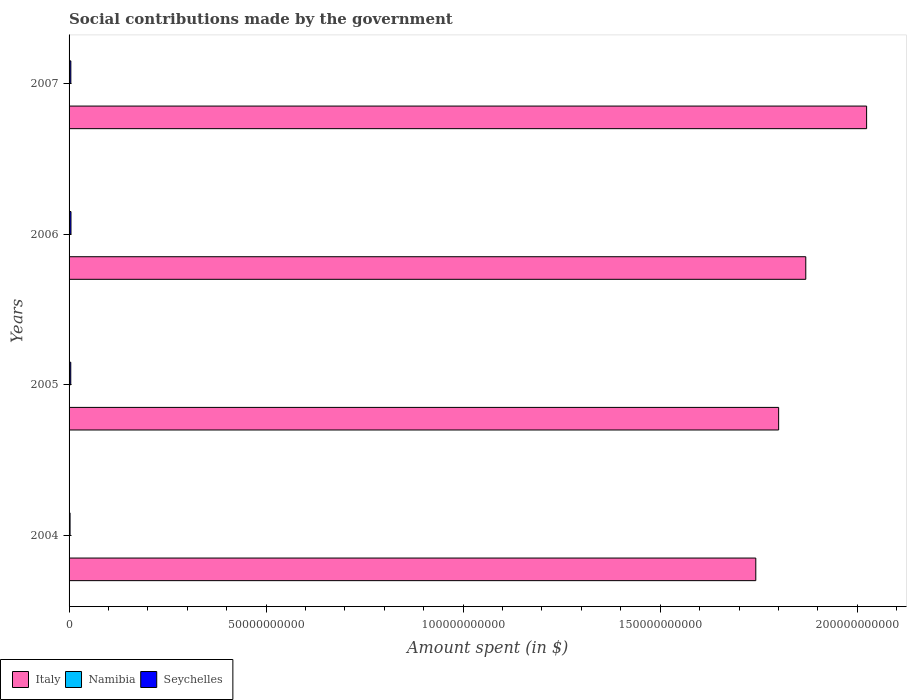How many different coloured bars are there?
Ensure brevity in your answer.  3. How many groups of bars are there?
Provide a succinct answer. 4. Are the number of bars on each tick of the Y-axis equal?
Keep it short and to the point. Yes. How many bars are there on the 4th tick from the bottom?
Offer a terse response. 3. In how many cases, is the number of bars for a given year not equal to the number of legend labels?
Give a very brief answer. 0. What is the amount spent on social contributions in Namibia in 2007?
Offer a very short reply. 8.14e+07. Across all years, what is the maximum amount spent on social contributions in Seychelles?
Your response must be concise. 4.84e+08. Across all years, what is the minimum amount spent on social contributions in Italy?
Offer a terse response. 1.74e+11. In which year was the amount spent on social contributions in Namibia maximum?
Ensure brevity in your answer.  2007. What is the total amount spent on social contributions in Seychelles in the graph?
Provide a short and direct response. 1.62e+09. What is the difference between the amount spent on social contributions in Italy in 2004 and that in 2005?
Your answer should be compact. -5.80e+09. What is the difference between the amount spent on social contributions in Namibia in 2004 and the amount spent on social contributions in Italy in 2006?
Provide a succinct answer. -1.87e+11. What is the average amount spent on social contributions in Namibia per year?
Keep it short and to the point. 7.55e+07. In the year 2005, what is the difference between the amount spent on social contributions in Namibia and amount spent on social contributions in Italy?
Ensure brevity in your answer.  -1.80e+11. In how many years, is the amount spent on social contributions in Italy greater than 90000000000 $?
Make the answer very short. 4. What is the ratio of the amount spent on social contributions in Italy in 2006 to that in 2007?
Your answer should be compact. 0.92. Is the amount spent on social contributions in Seychelles in 2005 less than that in 2006?
Offer a very short reply. Yes. Is the difference between the amount spent on social contributions in Namibia in 2004 and 2007 greater than the difference between the amount spent on social contributions in Italy in 2004 and 2007?
Provide a succinct answer. Yes. What is the difference between the highest and the second highest amount spent on social contributions in Namibia?
Ensure brevity in your answer.  4.47e+06. What is the difference between the highest and the lowest amount spent on social contributions in Namibia?
Offer a very short reply. 1.24e+07. In how many years, is the amount spent on social contributions in Italy greater than the average amount spent on social contributions in Italy taken over all years?
Your answer should be compact. 2. What does the 3rd bar from the top in 2007 represents?
Your answer should be compact. Italy. What does the 3rd bar from the bottom in 2006 represents?
Your response must be concise. Seychelles. How many bars are there?
Give a very brief answer. 12. Are all the bars in the graph horizontal?
Provide a short and direct response. Yes. What is the difference between two consecutive major ticks on the X-axis?
Make the answer very short. 5.00e+1. Are the values on the major ticks of X-axis written in scientific E-notation?
Your response must be concise. No. Does the graph contain grids?
Your answer should be compact. No. Where does the legend appear in the graph?
Make the answer very short. Bottom left. What is the title of the graph?
Offer a very short reply. Social contributions made by the government. What is the label or title of the X-axis?
Your answer should be very brief. Amount spent (in $). What is the label or title of the Y-axis?
Give a very brief answer. Years. What is the Amount spent (in $) in Italy in 2004?
Provide a succinct answer. 1.74e+11. What is the Amount spent (in $) of Namibia in 2004?
Offer a very short reply. 6.90e+07. What is the Amount spent (in $) of Seychelles in 2004?
Provide a short and direct response. 2.50e+08. What is the Amount spent (in $) of Italy in 2005?
Your response must be concise. 1.80e+11. What is the Amount spent (in $) of Namibia in 2005?
Provide a short and direct response. 7.69e+07. What is the Amount spent (in $) in Seychelles in 2005?
Keep it short and to the point. 4.32e+08. What is the Amount spent (in $) of Italy in 2006?
Make the answer very short. 1.87e+11. What is the Amount spent (in $) in Namibia in 2006?
Your response must be concise. 7.47e+07. What is the Amount spent (in $) in Seychelles in 2006?
Make the answer very short. 4.84e+08. What is the Amount spent (in $) in Italy in 2007?
Ensure brevity in your answer.  2.02e+11. What is the Amount spent (in $) of Namibia in 2007?
Keep it short and to the point. 8.14e+07. What is the Amount spent (in $) of Seychelles in 2007?
Ensure brevity in your answer.  4.50e+08. Across all years, what is the maximum Amount spent (in $) of Italy?
Provide a short and direct response. 2.02e+11. Across all years, what is the maximum Amount spent (in $) of Namibia?
Keep it short and to the point. 8.14e+07. Across all years, what is the maximum Amount spent (in $) in Seychelles?
Ensure brevity in your answer.  4.84e+08. Across all years, what is the minimum Amount spent (in $) in Italy?
Provide a succinct answer. 1.74e+11. Across all years, what is the minimum Amount spent (in $) of Namibia?
Your answer should be very brief. 6.90e+07. Across all years, what is the minimum Amount spent (in $) in Seychelles?
Provide a short and direct response. 2.50e+08. What is the total Amount spent (in $) in Italy in the graph?
Offer a terse response. 7.44e+11. What is the total Amount spent (in $) in Namibia in the graph?
Make the answer very short. 3.02e+08. What is the total Amount spent (in $) in Seychelles in the graph?
Offer a very short reply. 1.62e+09. What is the difference between the Amount spent (in $) in Italy in 2004 and that in 2005?
Make the answer very short. -5.80e+09. What is the difference between the Amount spent (in $) of Namibia in 2004 and that in 2005?
Your response must be concise. -7.95e+06. What is the difference between the Amount spent (in $) in Seychelles in 2004 and that in 2005?
Ensure brevity in your answer.  -1.82e+08. What is the difference between the Amount spent (in $) in Italy in 2004 and that in 2006?
Give a very brief answer. -1.27e+1. What is the difference between the Amount spent (in $) of Namibia in 2004 and that in 2006?
Your answer should be very brief. -5.71e+06. What is the difference between the Amount spent (in $) of Seychelles in 2004 and that in 2006?
Your answer should be compact. -2.33e+08. What is the difference between the Amount spent (in $) in Italy in 2004 and that in 2007?
Offer a terse response. -2.81e+1. What is the difference between the Amount spent (in $) in Namibia in 2004 and that in 2007?
Offer a terse response. -1.24e+07. What is the difference between the Amount spent (in $) of Seychelles in 2004 and that in 2007?
Offer a terse response. -2.00e+08. What is the difference between the Amount spent (in $) in Italy in 2005 and that in 2006?
Your response must be concise. -6.89e+09. What is the difference between the Amount spent (in $) of Namibia in 2005 and that in 2006?
Your answer should be very brief. 2.24e+06. What is the difference between the Amount spent (in $) of Seychelles in 2005 and that in 2006?
Provide a succinct answer. -5.19e+07. What is the difference between the Amount spent (in $) of Italy in 2005 and that in 2007?
Your answer should be very brief. -2.23e+1. What is the difference between the Amount spent (in $) of Namibia in 2005 and that in 2007?
Provide a short and direct response. -4.47e+06. What is the difference between the Amount spent (in $) of Seychelles in 2005 and that in 2007?
Provide a short and direct response. -1.84e+07. What is the difference between the Amount spent (in $) in Italy in 2006 and that in 2007?
Provide a succinct answer. -1.54e+1. What is the difference between the Amount spent (in $) in Namibia in 2006 and that in 2007?
Your answer should be compact. -6.71e+06. What is the difference between the Amount spent (in $) of Seychelles in 2006 and that in 2007?
Keep it short and to the point. 3.35e+07. What is the difference between the Amount spent (in $) of Italy in 2004 and the Amount spent (in $) of Namibia in 2005?
Your answer should be very brief. 1.74e+11. What is the difference between the Amount spent (in $) in Italy in 2004 and the Amount spent (in $) in Seychelles in 2005?
Make the answer very short. 1.74e+11. What is the difference between the Amount spent (in $) in Namibia in 2004 and the Amount spent (in $) in Seychelles in 2005?
Keep it short and to the point. -3.63e+08. What is the difference between the Amount spent (in $) of Italy in 2004 and the Amount spent (in $) of Namibia in 2006?
Make the answer very short. 1.74e+11. What is the difference between the Amount spent (in $) of Italy in 2004 and the Amount spent (in $) of Seychelles in 2006?
Provide a succinct answer. 1.74e+11. What is the difference between the Amount spent (in $) in Namibia in 2004 and the Amount spent (in $) in Seychelles in 2006?
Offer a very short reply. -4.15e+08. What is the difference between the Amount spent (in $) in Italy in 2004 and the Amount spent (in $) in Namibia in 2007?
Provide a succinct answer. 1.74e+11. What is the difference between the Amount spent (in $) in Italy in 2004 and the Amount spent (in $) in Seychelles in 2007?
Make the answer very short. 1.74e+11. What is the difference between the Amount spent (in $) of Namibia in 2004 and the Amount spent (in $) of Seychelles in 2007?
Give a very brief answer. -3.81e+08. What is the difference between the Amount spent (in $) in Italy in 2005 and the Amount spent (in $) in Namibia in 2006?
Your answer should be very brief. 1.80e+11. What is the difference between the Amount spent (in $) in Italy in 2005 and the Amount spent (in $) in Seychelles in 2006?
Ensure brevity in your answer.  1.80e+11. What is the difference between the Amount spent (in $) of Namibia in 2005 and the Amount spent (in $) of Seychelles in 2006?
Offer a very short reply. -4.07e+08. What is the difference between the Amount spent (in $) in Italy in 2005 and the Amount spent (in $) in Namibia in 2007?
Make the answer very short. 1.80e+11. What is the difference between the Amount spent (in $) of Italy in 2005 and the Amount spent (in $) of Seychelles in 2007?
Your answer should be very brief. 1.80e+11. What is the difference between the Amount spent (in $) of Namibia in 2005 and the Amount spent (in $) of Seychelles in 2007?
Provide a succinct answer. -3.73e+08. What is the difference between the Amount spent (in $) in Italy in 2006 and the Amount spent (in $) in Namibia in 2007?
Offer a terse response. 1.87e+11. What is the difference between the Amount spent (in $) of Italy in 2006 and the Amount spent (in $) of Seychelles in 2007?
Make the answer very short. 1.86e+11. What is the difference between the Amount spent (in $) of Namibia in 2006 and the Amount spent (in $) of Seychelles in 2007?
Keep it short and to the point. -3.76e+08. What is the average Amount spent (in $) in Italy per year?
Your answer should be compact. 1.86e+11. What is the average Amount spent (in $) of Namibia per year?
Your response must be concise. 7.55e+07. What is the average Amount spent (in $) of Seychelles per year?
Offer a very short reply. 4.04e+08. In the year 2004, what is the difference between the Amount spent (in $) of Italy and Amount spent (in $) of Namibia?
Provide a short and direct response. 1.74e+11. In the year 2004, what is the difference between the Amount spent (in $) of Italy and Amount spent (in $) of Seychelles?
Provide a succinct answer. 1.74e+11. In the year 2004, what is the difference between the Amount spent (in $) in Namibia and Amount spent (in $) in Seychelles?
Provide a succinct answer. -1.81e+08. In the year 2005, what is the difference between the Amount spent (in $) in Italy and Amount spent (in $) in Namibia?
Offer a terse response. 1.80e+11. In the year 2005, what is the difference between the Amount spent (in $) of Italy and Amount spent (in $) of Seychelles?
Give a very brief answer. 1.80e+11. In the year 2005, what is the difference between the Amount spent (in $) in Namibia and Amount spent (in $) in Seychelles?
Your answer should be compact. -3.55e+08. In the year 2006, what is the difference between the Amount spent (in $) in Italy and Amount spent (in $) in Namibia?
Your answer should be very brief. 1.87e+11. In the year 2006, what is the difference between the Amount spent (in $) of Italy and Amount spent (in $) of Seychelles?
Make the answer very short. 1.86e+11. In the year 2006, what is the difference between the Amount spent (in $) of Namibia and Amount spent (in $) of Seychelles?
Your answer should be compact. -4.09e+08. In the year 2007, what is the difference between the Amount spent (in $) of Italy and Amount spent (in $) of Namibia?
Give a very brief answer. 2.02e+11. In the year 2007, what is the difference between the Amount spent (in $) in Italy and Amount spent (in $) in Seychelles?
Your response must be concise. 2.02e+11. In the year 2007, what is the difference between the Amount spent (in $) in Namibia and Amount spent (in $) in Seychelles?
Provide a short and direct response. -3.69e+08. What is the ratio of the Amount spent (in $) of Italy in 2004 to that in 2005?
Give a very brief answer. 0.97. What is the ratio of the Amount spent (in $) in Namibia in 2004 to that in 2005?
Your answer should be very brief. 0.9. What is the ratio of the Amount spent (in $) of Seychelles in 2004 to that in 2005?
Keep it short and to the point. 0.58. What is the ratio of the Amount spent (in $) of Italy in 2004 to that in 2006?
Give a very brief answer. 0.93. What is the ratio of the Amount spent (in $) of Namibia in 2004 to that in 2006?
Your response must be concise. 0.92. What is the ratio of the Amount spent (in $) in Seychelles in 2004 to that in 2006?
Offer a very short reply. 0.52. What is the ratio of the Amount spent (in $) of Italy in 2004 to that in 2007?
Offer a very short reply. 0.86. What is the ratio of the Amount spent (in $) in Namibia in 2004 to that in 2007?
Offer a very short reply. 0.85. What is the ratio of the Amount spent (in $) in Seychelles in 2004 to that in 2007?
Offer a terse response. 0.56. What is the ratio of the Amount spent (in $) in Italy in 2005 to that in 2006?
Your answer should be very brief. 0.96. What is the ratio of the Amount spent (in $) in Namibia in 2005 to that in 2006?
Offer a terse response. 1.03. What is the ratio of the Amount spent (in $) in Seychelles in 2005 to that in 2006?
Provide a short and direct response. 0.89. What is the ratio of the Amount spent (in $) in Italy in 2005 to that in 2007?
Make the answer very short. 0.89. What is the ratio of the Amount spent (in $) of Namibia in 2005 to that in 2007?
Make the answer very short. 0.95. What is the ratio of the Amount spent (in $) of Seychelles in 2005 to that in 2007?
Keep it short and to the point. 0.96. What is the ratio of the Amount spent (in $) of Italy in 2006 to that in 2007?
Ensure brevity in your answer.  0.92. What is the ratio of the Amount spent (in $) of Namibia in 2006 to that in 2007?
Ensure brevity in your answer.  0.92. What is the ratio of the Amount spent (in $) in Seychelles in 2006 to that in 2007?
Provide a succinct answer. 1.07. What is the difference between the highest and the second highest Amount spent (in $) of Italy?
Your answer should be compact. 1.54e+1. What is the difference between the highest and the second highest Amount spent (in $) in Namibia?
Provide a succinct answer. 4.47e+06. What is the difference between the highest and the second highest Amount spent (in $) in Seychelles?
Provide a succinct answer. 3.35e+07. What is the difference between the highest and the lowest Amount spent (in $) of Italy?
Your answer should be compact. 2.81e+1. What is the difference between the highest and the lowest Amount spent (in $) of Namibia?
Offer a very short reply. 1.24e+07. What is the difference between the highest and the lowest Amount spent (in $) of Seychelles?
Make the answer very short. 2.33e+08. 